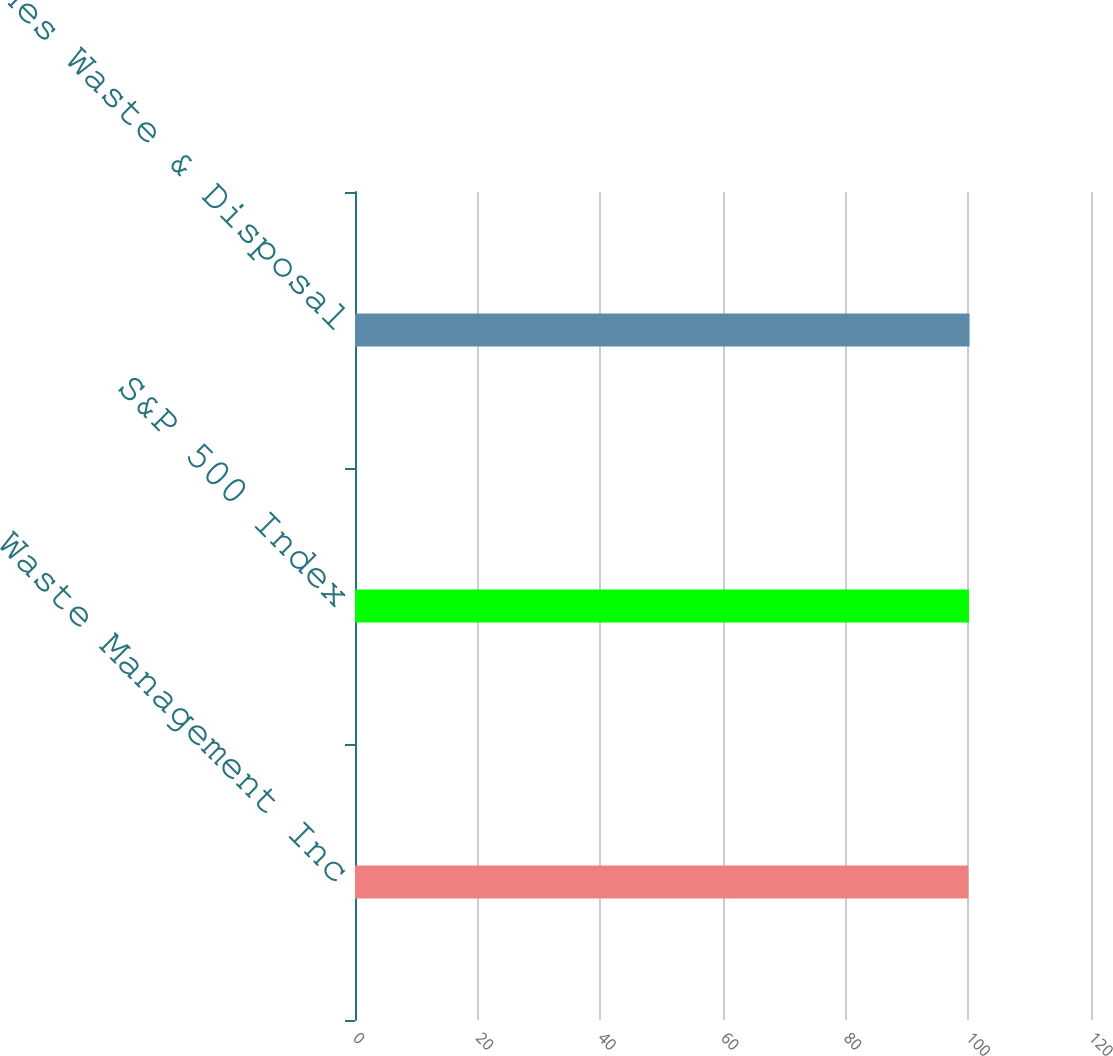<chart> <loc_0><loc_0><loc_500><loc_500><bar_chart><fcel>Waste Management Inc<fcel>S&P 500 Index<fcel>Dow Jones Waste & Disposal<nl><fcel>100<fcel>100.1<fcel>100.2<nl></chart> 